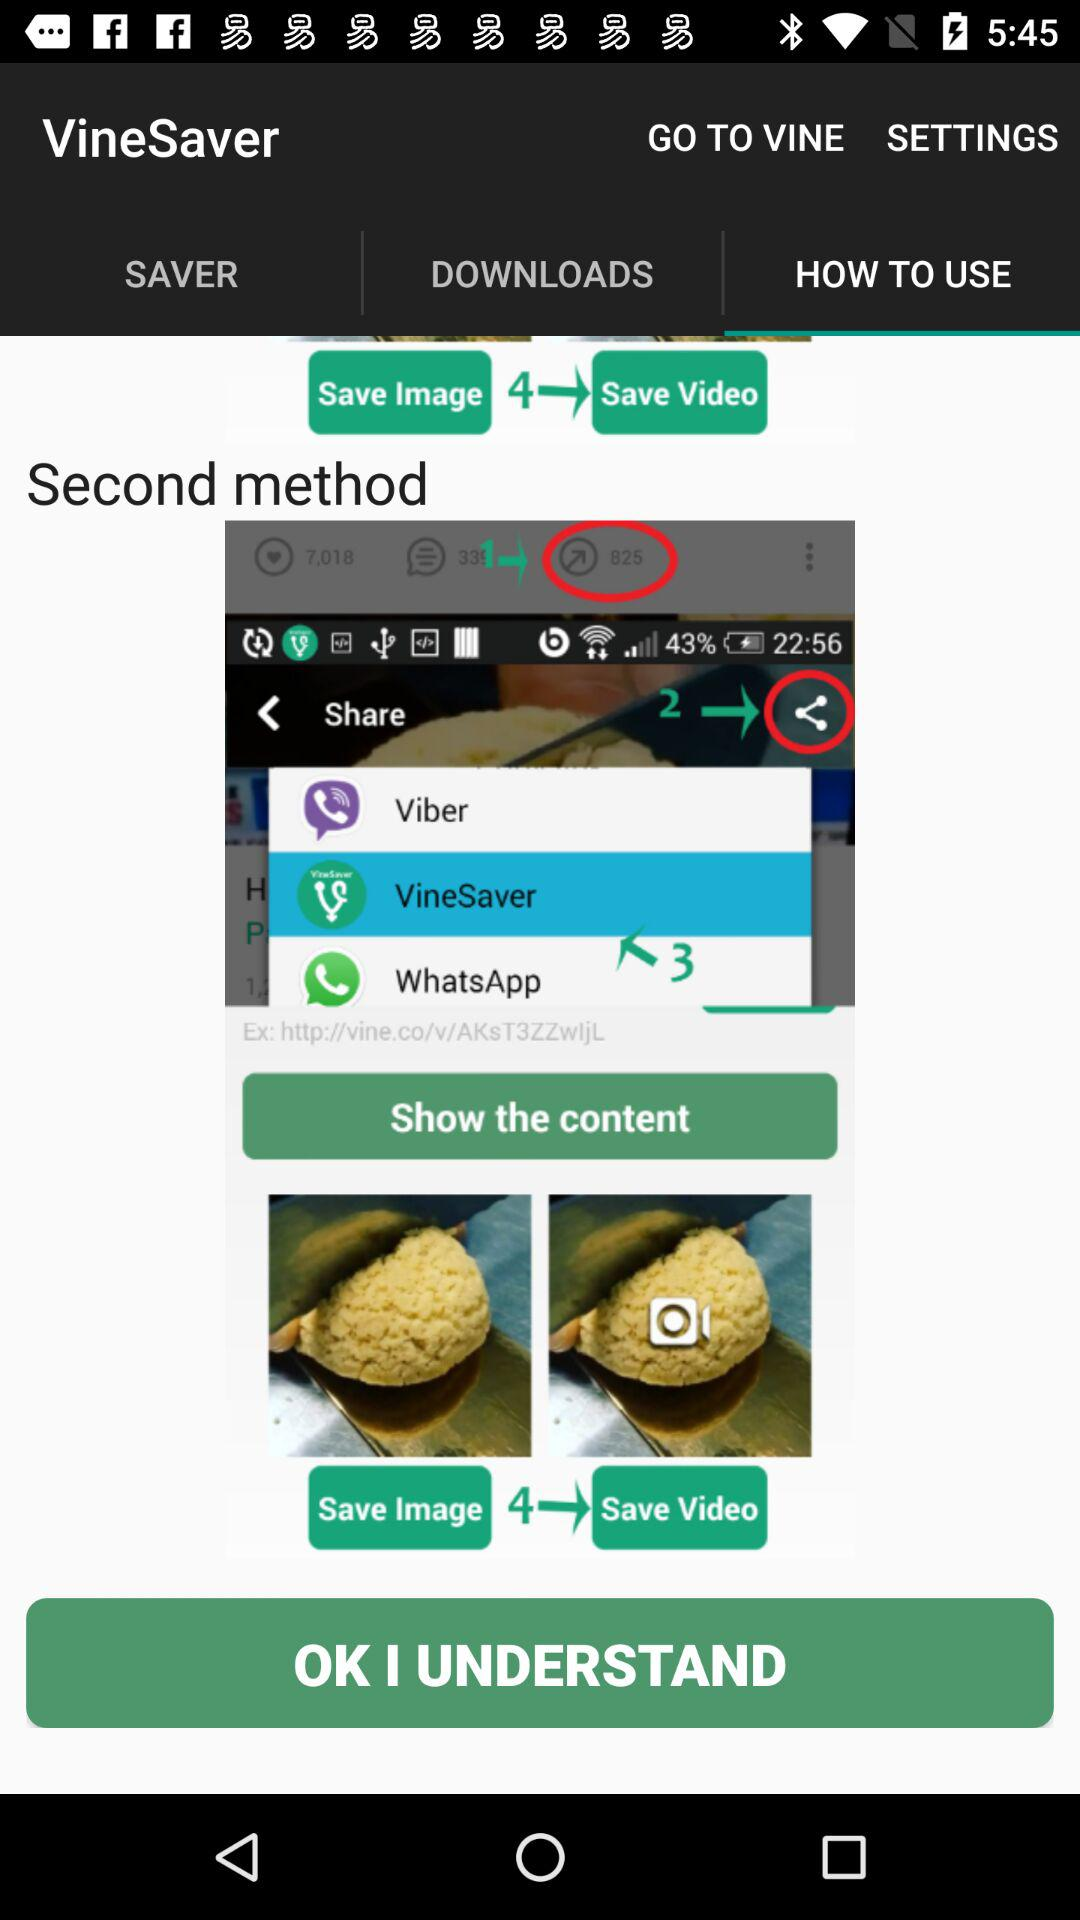Which tab is selected? The tab "HOW TO USE" is selected. 